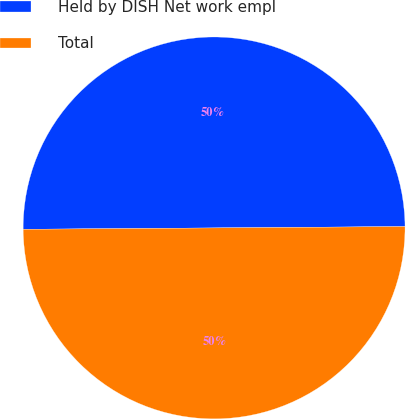Convert chart to OTSL. <chart><loc_0><loc_0><loc_500><loc_500><pie_chart><fcel>Held by DISH Net work empl<fcel>Total<nl><fcel>50.0%<fcel>50.0%<nl></chart> 